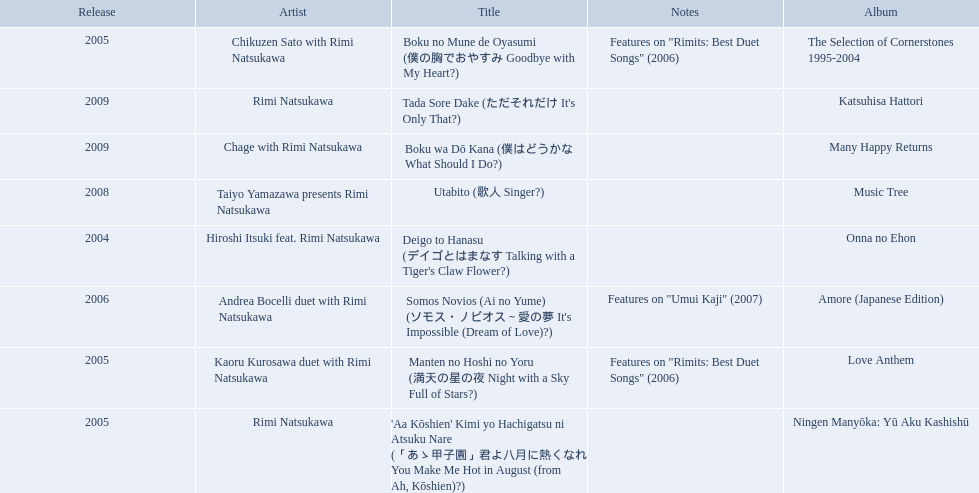What year was onna no ehon released? 2004. What year was music tree released? 2008. Which of the two was not released in 2004? Music Tree. 